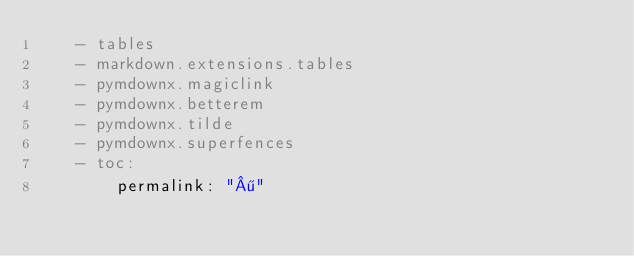Convert code to text. <code><loc_0><loc_0><loc_500><loc_500><_YAML_>    - tables
    - markdown.extensions.tables
    - pymdownx.magiclink
    - pymdownx.betterem
    - pymdownx.tilde
    - pymdownx.superfences
    - toc:
        permalink: "¶"
</code> 